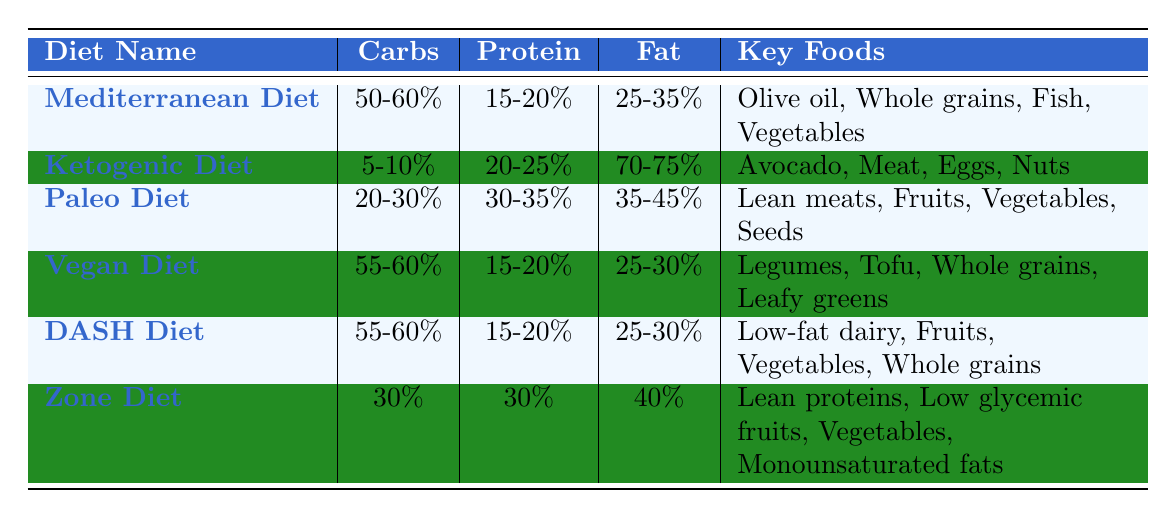What is the protein percentage in the Ketogenic Diet? The Ketogenic Diet has a macronutrient ratio of 20-25% protein listed in the table.
Answer: 20-25% Which diet has the highest fat percentage? The Ketogenic Diet has the highest fat percentage at 70-75%, according to the table.
Answer: Ketogenic Diet Is the Paleo Diet higher in carbohydrates than the Vegan Diet? The Paleo Diet has a carbohydrate ratio of 20-30%, while the Vegan Diet has 55-60%. Therefore, the Paleo Diet is not higher in carbohydrates.
Answer: No What is the average carbohydrate percentage among the Mediterranean and DASH diets? The Mediterranean Diet has 50-60% and the DASH Diet has 55-60%. The average is calculated by taking the midpoint: (55 + 50) / 2 = 52.5%, for each range.
Answer: 52.5% Which diet includes "Legumes" as a key food? The table shows that the Vegan Diet includes "Legumes" in its key foods.
Answer: Vegan Diet How many diets have a protein ratio of at least 30%? The Paleo Diet (30-35%) and the Ketogenic Diet (20-25%) fit into this category, so I will check each one. Only the Paleo Diet has at least 30%. Therefore, there is one diet.
Answer: 1 Is the fat ratio for the Zone Diet higher than that of the Mediterranean Diet? The Zone Diet has a fat percentage of 40%, while the Mediterranean Diet has 25-35%. Since 40% is greater than 35%, the Zone Diet has a higher fat ratio.
Answer: Yes Considering the fat ratios only, is there a diet with less than 30% fat? The Mediterranean, Vegan, and DASH diets have fat percentages between 25-30%; thus, all are below 30%.
Answer: Yes How do the protein ratios of the Mediterranean and Vegan diets compare? The Mediterranean Diet has 15-20% protein, and the Vegan Diet also has 15-20%. They share the same protein ratio range.
Answer: Same What is the difference in carbohydrate percentage between the Ketogenic Diet and the Paleo Diet? The Ketogenic Diet has 5-10% and the Paleo Diet has 20-30%. Taking the maximum each has, the difference would be 20% - 10% = 10%.
Answer: 10% 